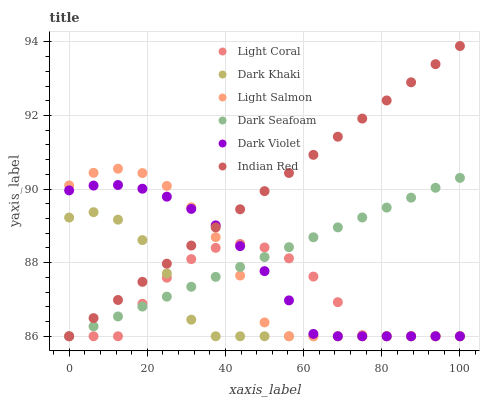Does Dark Khaki have the minimum area under the curve?
Answer yes or no. Yes. Does Indian Red have the maximum area under the curve?
Answer yes or no. Yes. Does Light Salmon have the minimum area under the curve?
Answer yes or no. No. Does Light Salmon have the maximum area under the curve?
Answer yes or no. No. Is Dark Seafoam the smoothest?
Answer yes or no. Yes. Is Light Coral the roughest?
Answer yes or no. Yes. Is Light Salmon the smoothest?
Answer yes or no. No. Is Light Salmon the roughest?
Answer yes or no. No. Does Dark Khaki have the lowest value?
Answer yes or no. Yes. Does Indian Red have the highest value?
Answer yes or no. Yes. Does Light Salmon have the highest value?
Answer yes or no. No. Does Dark Seafoam intersect Dark Violet?
Answer yes or no. Yes. Is Dark Seafoam less than Dark Violet?
Answer yes or no. No. Is Dark Seafoam greater than Dark Violet?
Answer yes or no. No. 